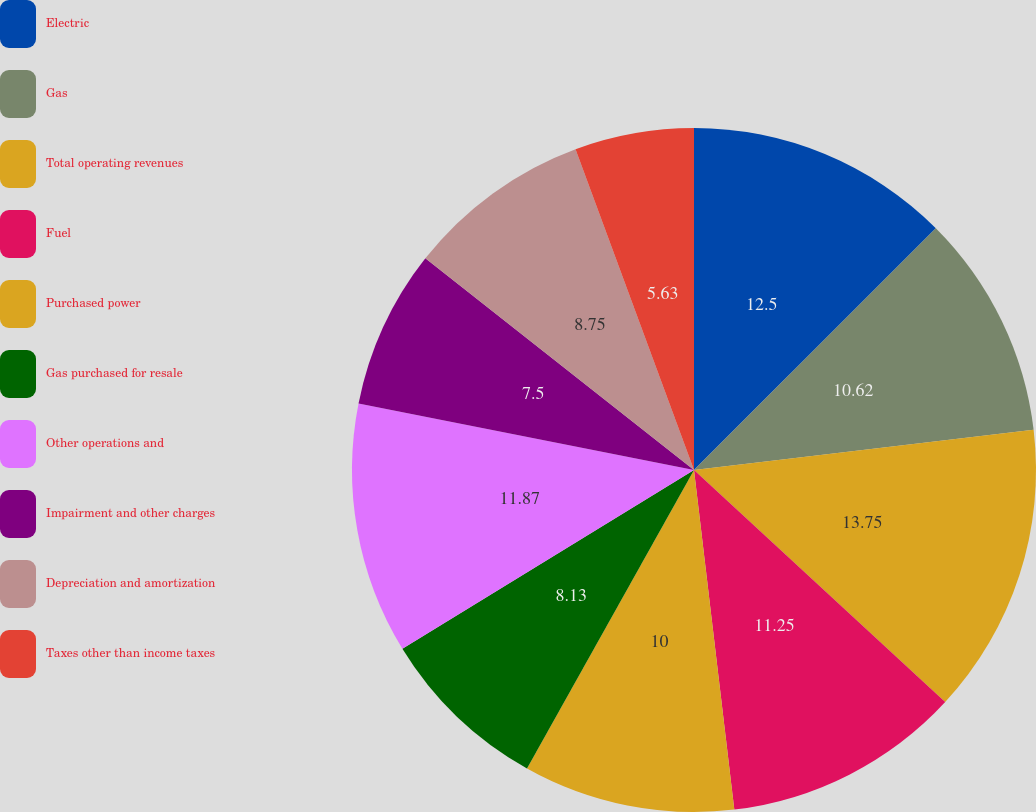<chart> <loc_0><loc_0><loc_500><loc_500><pie_chart><fcel>Electric<fcel>Gas<fcel>Total operating revenues<fcel>Fuel<fcel>Purchased power<fcel>Gas purchased for resale<fcel>Other operations and<fcel>Impairment and other charges<fcel>Depreciation and amortization<fcel>Taxes other than income taxes<nl><fcel>12.5%<fcel>10.62%<fcel>13.75%<fcel>11.25%<fcel>10.0%<fcel>8.13%<fcel>11.87%<fcel>7.5%<fcel>8.75%<fcel>5.63%<nl></chart> 